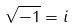<formula> <loc_0><loc_0><loc_500><loc_500>\sqrt { - 1 } = i</formula> 